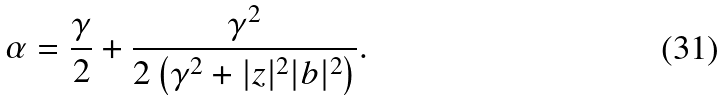<formula> <loc_0><loc_0><loc_500><loc_500>\alpha = \frac { \gamma } { 2 } + \frac { \gamma ^ { 2 } } { 2 \left ( \gamma ^ { 2 } + | z | ^ { 2 } | b | ^ { 2 } \right ) } .</formula> 